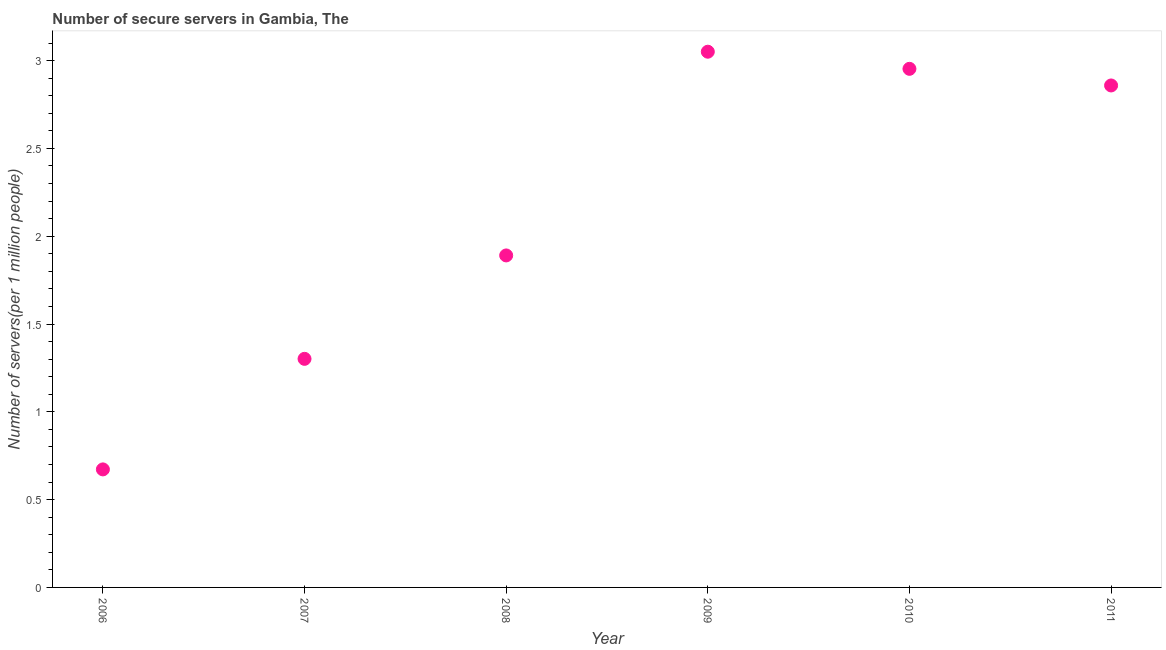What is the number of secure internet servers in 2008?
Your answer should be compact. 1.89. Across all years, what is the maximum number of secure internet servers?
Your answer should be compact. 3.05. Across all years, what is the minimum number of secure internet servers?
Ensure brevity in your answer.  0.67. What is the sum of the number of secure internet servers?
Offer a terse response. 12.73. What is the difference between the number of secure internet servers in 2009 and 2010?
Your answer should be compact. 0.1. What is the average number of secure internet servers per year?
Provide a succinct answer. 2.12. What is the median number of secure internet servers?
Your answer should be very brief. 2.37. In how many years, is the number of secure internet servers greater than 1.3 ?
Offer a terse response. 5. What is the ratio of the number of secure internet servers in 2006 to that in 2009?
Offer a very short reply. 0.22. What is the difference between the highest and the second highest number of secure internet servers?
Your response must be concise. 0.1. What is the difference between the highest and the lowest number of secure internet servers?
Your response must be concise. 2.38. Does the number of secure internet servers monotonically increase over the years?
Offer a terse response. No. How many dotlines are there?
Your answer should be very brief. 1. How many years are there in the graph?
Your answer should be compact. 6. What is the difference between two consecutive major ticks on the Y-axis?
Ensure brevity in your answer.  0.5. Does the graph contain any zero values?
Keep it short and to the point. No. Does the graph contain grids?
Your response must be concise. No. What is the title of the graph?
Provide a short and direct response. Number of secure servers in Gambia, The. What is the label or title of the Y-axis?
Your response must be concise. Number of servers(per 1 million people). What is the Number of servers(per 1 million people) in 2006?
Offer a terse response. 0.67. What is the Number of servers(per 1 million people) in 2007?
Ensure brevity in your answer.  1.3. What is the Number of servers(per 1 million people) in 2008?
Keep it short and to the point. 1.89. What is the Number of servers(per 1 million people) in 2009?
Make the answer very short. 3.05. What is the Number of servers(per 1 million people) in 2010?
Your answer should be very brief. 2.95. What is the Number of servers(per 1 million people) in 2011?
Offer a very short reply. 2.86. What is the difference between the Number of servers(per 1 million people) in 2006 and 2007?
Make the answer very short. -0.63. What is the difference between the Number of servers(per 1 million people) in 2006 and 2008?
Offer a terse response. -1.22. What is the difference between the Number of servers(per 1 million people) in 2006 and 2009?
Provide a succinct answer. -2.38. What is the difference between the Number of servers(per 1 million people) in 2006 and 2010?
Your response must be concise. -2.28. What is the difference between the Number of servers(per 1 million people) in 2006 and 2011?
Your response must be concise. -2.19. What is the difference between the Number of servers(per 1 million people) in 2007 and 2008?
Provide a succinct answer. -0.59. What is the difference between the Number of servers(per 1 million people) in 2007 and 2009?
Give a very brief answer. -1.75. What is the difference between the Number of servers(per 1 million people) in 2007 and 2010?
Offer a very short reply. -1.65. What is the difference between the Number of servers(per 1 million people) in 2007 and 2011?
Provide a short and direct response. -1.56. What is the difference between the Number of servers(per 1 million people) in 2008 and 2009?
Offer a terse response. -1.16. What is the difference between the Number of servers(per 1 million people) in 2008 and 2010?
Offer a very short reply. -1.06. What is the difference between the Number of servers(per 1 million people) in 2008 and 2011?
Your answer should be very brief. -0.97. What is the difference between the Number of servers(per 1 million people) in 2009 and 2010?
Ensure brevity in your answer.  0.1. What is the difference between the Number of servers(per 1 million people) in 2009 and 2011?
Your answer should be compact. 0.19. What is the difference between the Number of servers(per 1 million people) in 2010 and 2011?
Offer a terse response. 0.09. What is the ratio of the Number of servers(per 1 million people) in 2006 to that in 2007?
Offer a very short reply. 0.52. What is the ratio of the Number of servers(per 1 million people) in 2006 to that in 2008?
Ensure brevity in your answer.  0.36. What is the ratio of the Number of servers(per 1 million people) in 2006 to that in 2009?
Make the answer very short. 0.22. What is the ratio of the Number of servers(per 1 million people) in 2006 to that in 2010?
Provide a succinct answer. 0.23. What is the ratio of the Number of servers(per 1 million people) in 2006 to that in 2011?
Your answer should be compact. 0.23. What is the ratio of the Number of servers(per 1 million people) in 2007 to that in 2008?
Give a very brief answer. 0.69. What is the ratio of the Number of servers(per 1 million people) in 2007 to that in 2009?
Offer a very short reply. 0.43. What is the ratio of the Number of servers(per 1 million people) in 2007 to that in 2010?
Ensure brevity in your answer.  0.44. What is the ratio of the Number of servers(per 1 million people) in 2007 to that in 2011?
Keep it short and to the point. 0.46. What is the ratio of the Number of servers(per 1 million people) in 2008 to that in 2009?
Offer a terse response. 0.62. What is the ratio of the Number of servers(per 1 million people) in 2008 to that in 2010?
Give a very brief answer. 0.64. What is the ratio of the Number of servers(per 1 million people) in 2008 to that in 2011?
Make the answer very short. 0.66. What is the ratio of the Number of servers(per 1 million people) in 2009 to that in 2010?
Make the answer very short. 1.03. What is the ratio of the Number of servers(per 1 million people) in 2009 to that in 2011?
Provide a succinct answer. 1.07. What is the ratio of the Number of servers(per 1 million people) in 2010 to that in 2011?
Ensure brevity in your answer.  1.03. 